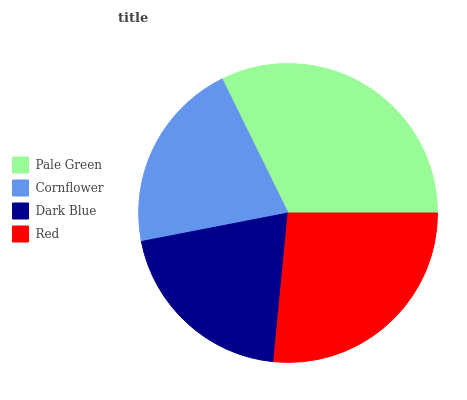Is Dark Blue the minimum?
Answer yes or no. Yes. Is Pale Green the maximum?
Answer yes or no. Yes. Is Cornflower the minimum?
Answer yes or no. No. Is Cornflower the maximum?
Answer yes or no. No. Is Pale Green greater than Cornflower?
Answer yes or no. Yes. Is Cornflower less than Pale Green?
Answer yes or no. Yes. Is Cornflower greater than Pale Green?
Answer yes or no. No. Is Pale Green less than Cornflower?
Answer yes or no. No. Is Red the high median?
Answer yes or no. Yes. Is Cornflower the low median?
Answer yes or no. Yes. Is Dark Blue the high median?
Answer yes or no. No. Is Pale Green the low median?
Answer yes or no. No. 